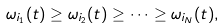Convert formula to latex. <formula><loc_0><loc_0><loc_500><loc_500>\omega _ { i _ { 1 } } ( t ) \geq \omega _ { i _ { 2 } } ( t ) \geq \cdots \geq \omega _ { i _ { N } } ( t ) ,</formula> 